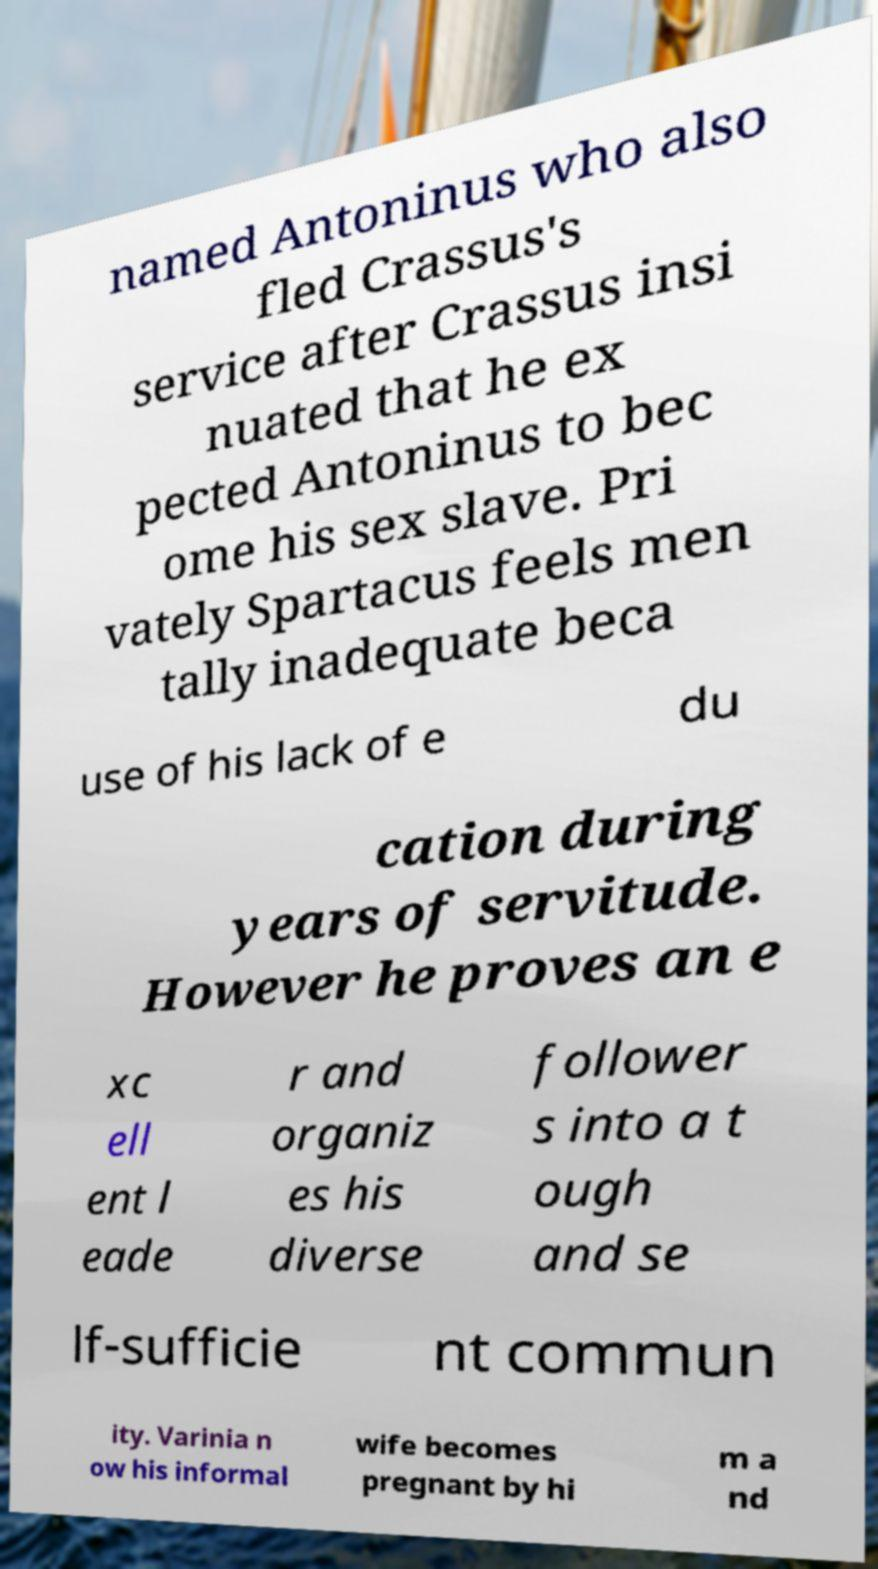Could you assist in decoding the text presented in this image and type it out clearly? named Antoninus who also fled Crassus's service after Crassus insi nuated that he ex pected Antoninus to bec ome his sex slave. Pri vately Spartacus feels men tally inadequate beca use of his lack of e du cation during years of servitude. However he proves an e xc ell ent l eade r and organiz es his diverse follower s into a t ough and se lf-sufficie nt commun ity. Varinia n ow his informal wife becomes pregnant by hi m a nd 